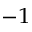Convert formula to latex. <formula><loc_0><loc_0><loc_500><loc_500>^ { - 1 }</formula> 